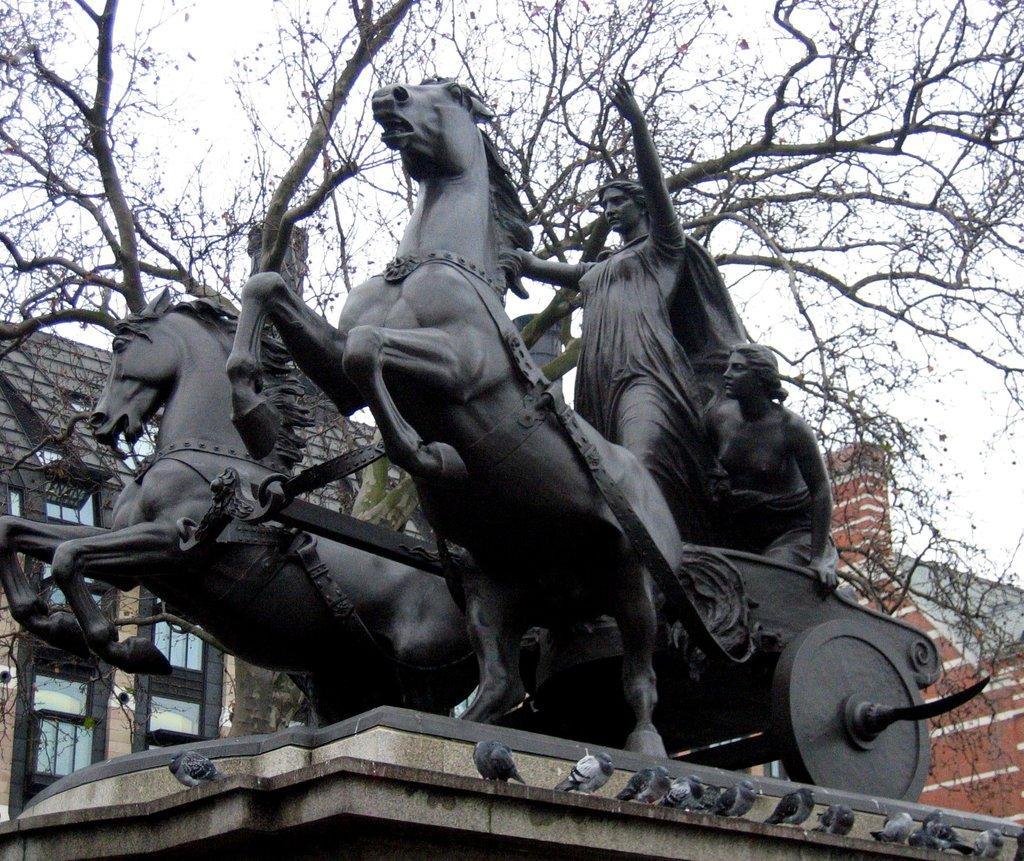Please provide a concise description of this image. In this picture there is a statue of two women riding a horse and in the backdrop the buildings tree and sky 